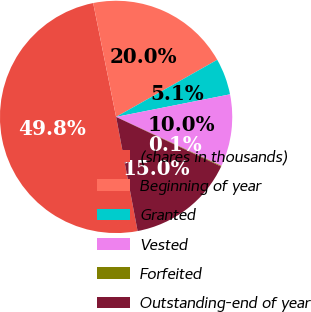<chart> <loc_0><loc_0><loc_500><loc_500><pie_chart><fcel>(shares in thousands)<fcel>Beginning of year<fcel>Granted<fcel>Vested<fcel>Forfeited<fcel>Outstanding-end of year<nl><fcel>49.8%<fcel>19.98%<fcel>5.07%<fcel>10.04%<fcel>0.1%<fcel>15.01%<nl></chart> 